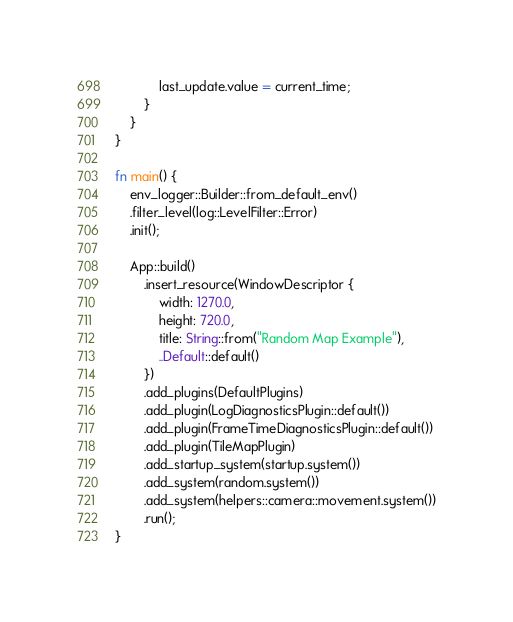Convert code to text. <code><loc_0><loc_0><loc_500><loc_500><_Rust_>            last_update.value = current_time;
        }
    }
}

fn main() {
    env_logger::Builder::from_default_env()
    .filter_level(log::LevelFilter::Error)
    .init();

    App::build()
        .insert_resource(WindowDescriptor {
            width: 1270.0,
            height: 720.0,
            title: String::from("Random Map Example"),
            ..Default::default()
        })
        .add_plugins(DefaultPlugins)
        .add_plugin(LogDiagnosticsPlugin::default())
        .add_plugin(FrameTimeDiagnosticsPlugin::default())
        .add_plugin(TileMapPlugin)
        .add_startup_system(startup.system())
        .add_system(random.system())
        .add_system(helpers::camera::movement.system())
        .run();
}
</code> 